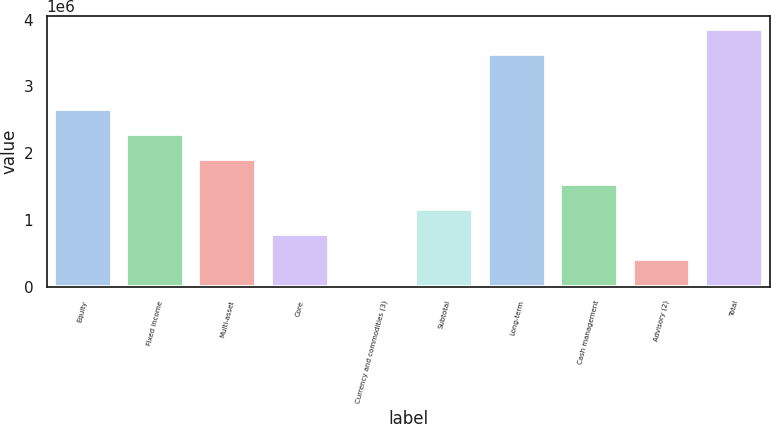Convert chart. <chart><loc_0><loc_0><loc_500><loc_500><bar_chart><fcel>Equity<fcel>Fixed income<fcel>Multi-asset<fcel>Core<fcel>Currency and commodities (3)<fcel>Subtotal<fcel>Long-term<fcel>Cash management<fcel>Advisory (2)<fcel>Total<nl><fcel>2.66654e+06<fcel>2.29152e+06<fcel>1.91651e+06<fcel>791460<fcel>41428<fcel>1.16648e+06<fcel>3.48237e+06<fcel>1.54149e+06<fcel>416444<fcel>3.85738e+06<nl></chart> 